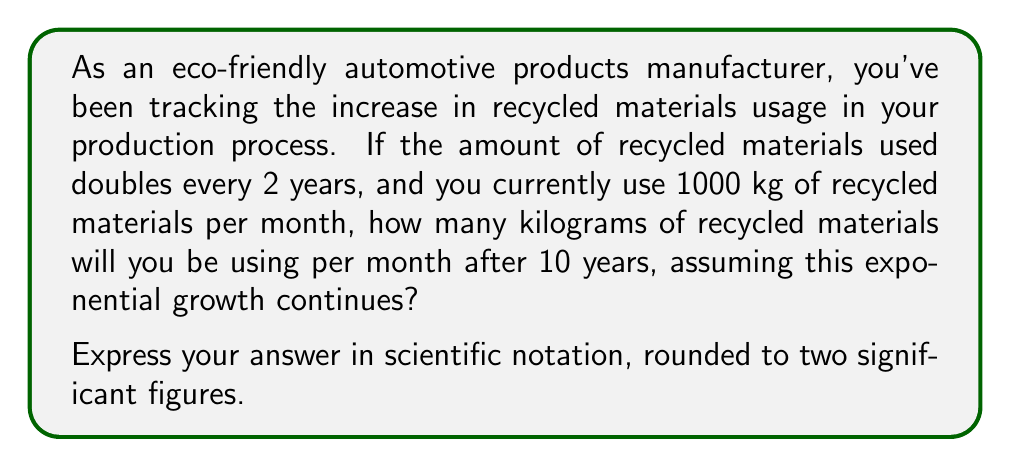Help me with this question. Let's approach this step-by-step:

1) First, we need to identify the key components of exponential growth:
   - Initial amount: $a = 1000$ kg
   - Growth factor: doubles (×2) every 2 years
   - Time period: 10 years

2) We can express this as an exponential function:
   $$ A = a \cdot r^n $$
   Where:
   $A$ is the final amount
   $a$ is the initial amount
   $r$ is the growth factor per time period
   $n$ is the number of time periods

3) In this case:
   - $r = 2$ (doubles)
   - $n = 10 \div 2 = 5$ (because it doubles every 2 years, and we're looking at a 10-year period)

4) Now we can plug these values into our equation:
   $$ A = 1000 \cdot 2^5 $$

5) Let's calculate $2^5$:
   $$ 2^5 = 2 \cdot 2 \cdot 2 \cdot 2 \cdot 2 = 32 $$

6) Now we can complete our calculation:
   $$ A = 1000 \cdot 32 = 32,000 $$

7) The question asks for the answer in scientific notation, rounded to two significant figures:
   $$ 32,000 = 3.2 \times 10^4 $$

Therefore, after 10 years, you will be using approximately $3.2 \times 10^4$ kg of recycled materials per month.
Answer: $3.2 \times 10^4$ kg 